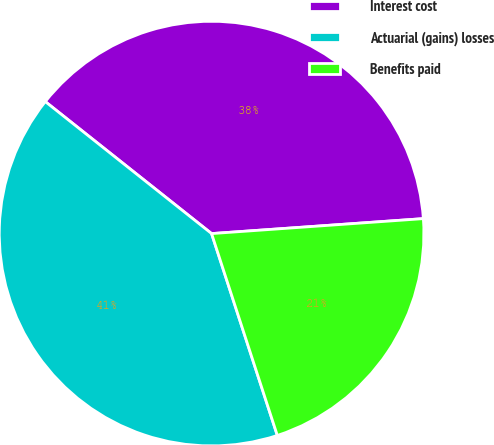Convert chart to OTSL. <chart><loc_0><loc_0><loc_500><loc_500><pie_chart><fcel>Interest cost<fcel>Actuarial (gains) losses<fcel>Benefits paid<nl><fcel>38.2%<fcel>40.69%<fcel>21.11%<nl></chart> 